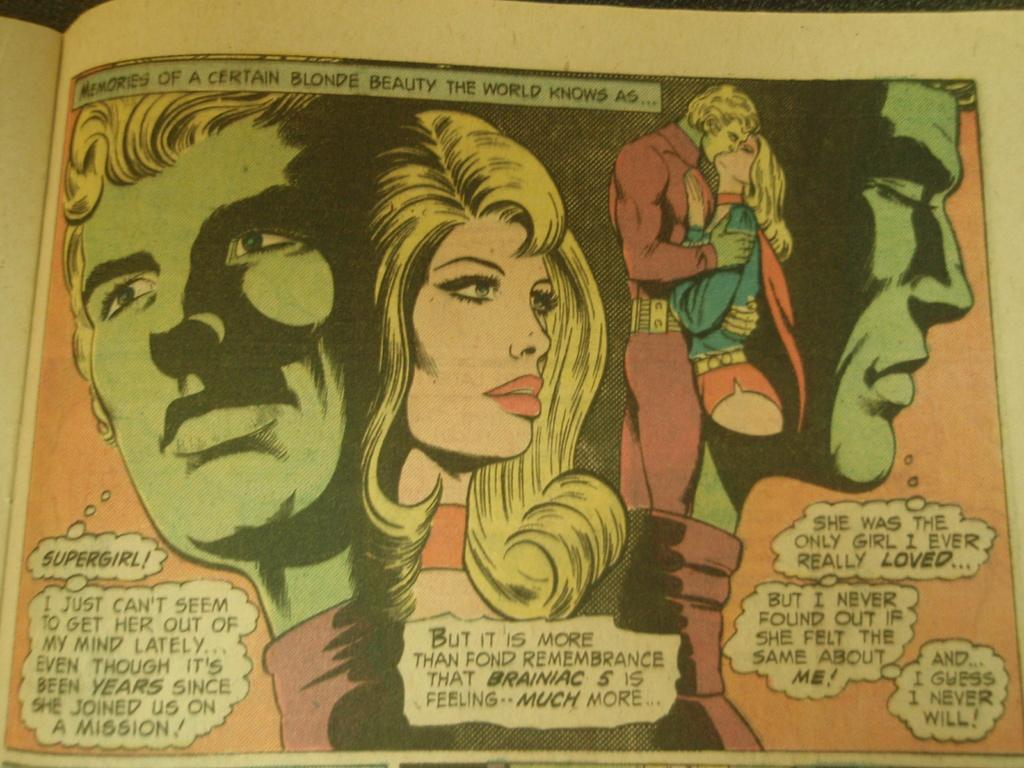<image>
Describe the image concisely. A comic book panel concerns a smitten admirer of the superhero known as Supergirl. 